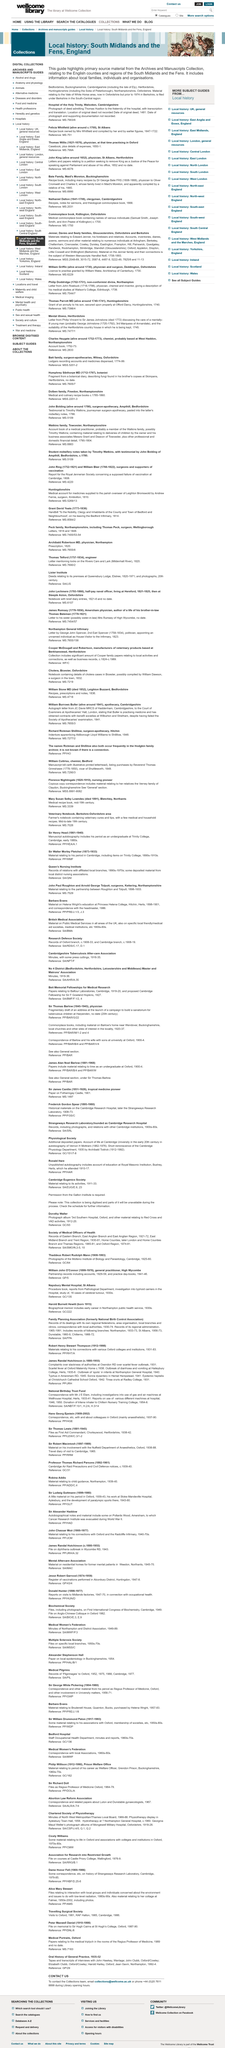Highlight a few significant elements in this photo. Material related to the Vale of White Horse area is filed under the Berkshire region in the South-Central region of the United Kingdom. The local history guide provides information on local families, individuals, and organizations. The country of England is being highlighted by this local history guide. 